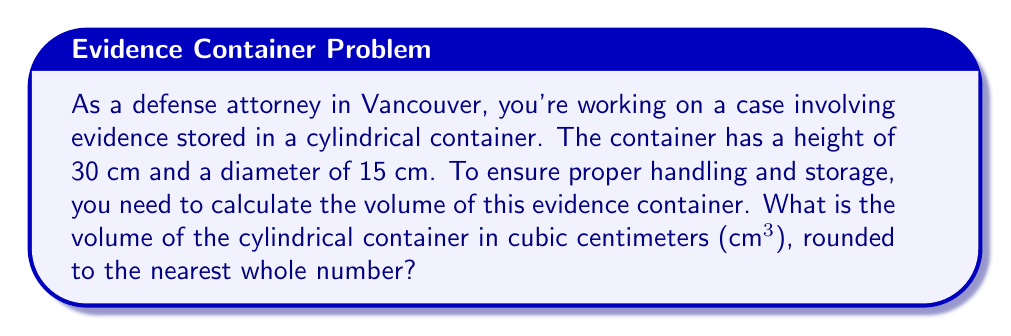Help me with this question. To find the volume of a cylindrical container, we use the formula:

$$V = \pi r^2 h$$

Where:
$V$ = volume
$\pi$ = pi (approximately 3.14159)
$r$ = radius of the base
$h$ = height of the cylinder

Given:
- Height (h) = 30 cm
- Diameter = 15 cm

Step 1: Calculate the radius
The radius is half the diameter:
$r = 15 \text{ cm} \div 2 = 7.5 \text{ cm}$

Step 2: Apply the volume formula
$$\begin{align*}
V &= \pi r^2 h \\
&= \pi (7.5 \text{ cm})^2 (30 \text{ cm}) \\
&= \pi (56.25 \text{ cm}^2) (30 \text{ cm}) \\
&= 1,696.46... \text{ cm}^3
\end{align*}$$

Step 3: Round to the nearest whole number
1,696.46... cm³ rounds to 1,696 cm³

[asy]
import geometry;

size(200);
real r = 2;
real h = 4;

path base = circle((0,0),r);
path top = circle((0,h),r);

draw(base);
draw(top);
draw((r,0)--(r,h));
draw((-r,0)--(-r,h));
draw((0,h)--(r,h),dashed);
draw((0,0)--(r,0),dashed);

label("r", (r/2,0), S);
label("h", (r,h/2), E);

</asy>
Answer: The volume of the cylindrical evidence container is 1,696 cm³. 